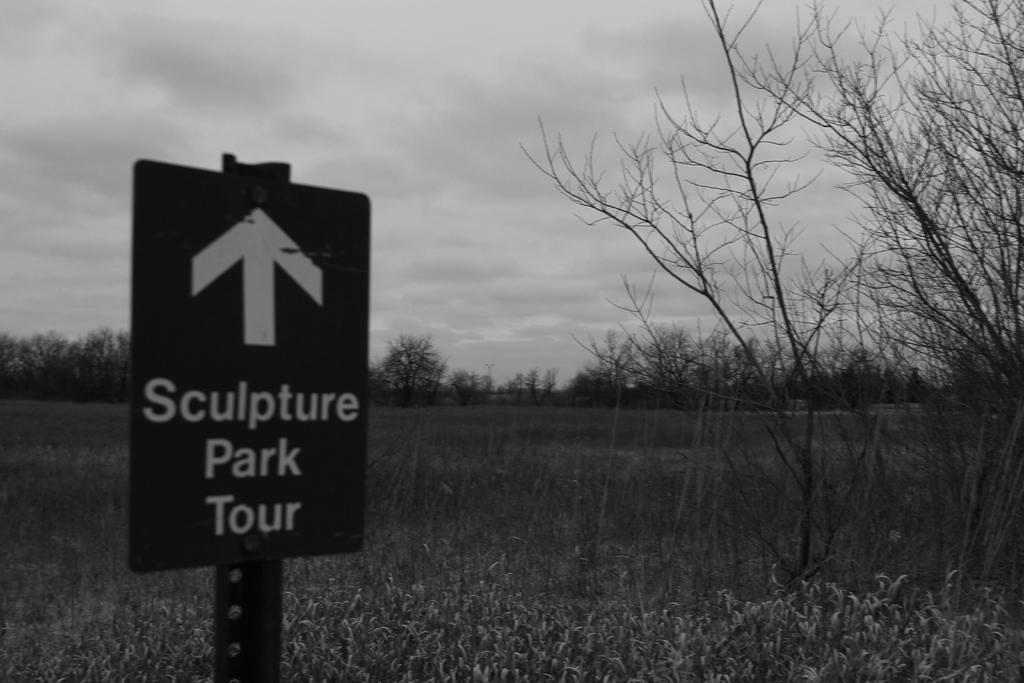Can you describe this image briefly? This is a black and white image. In this image we can see sign board, plants, trees, sky and clouds. 